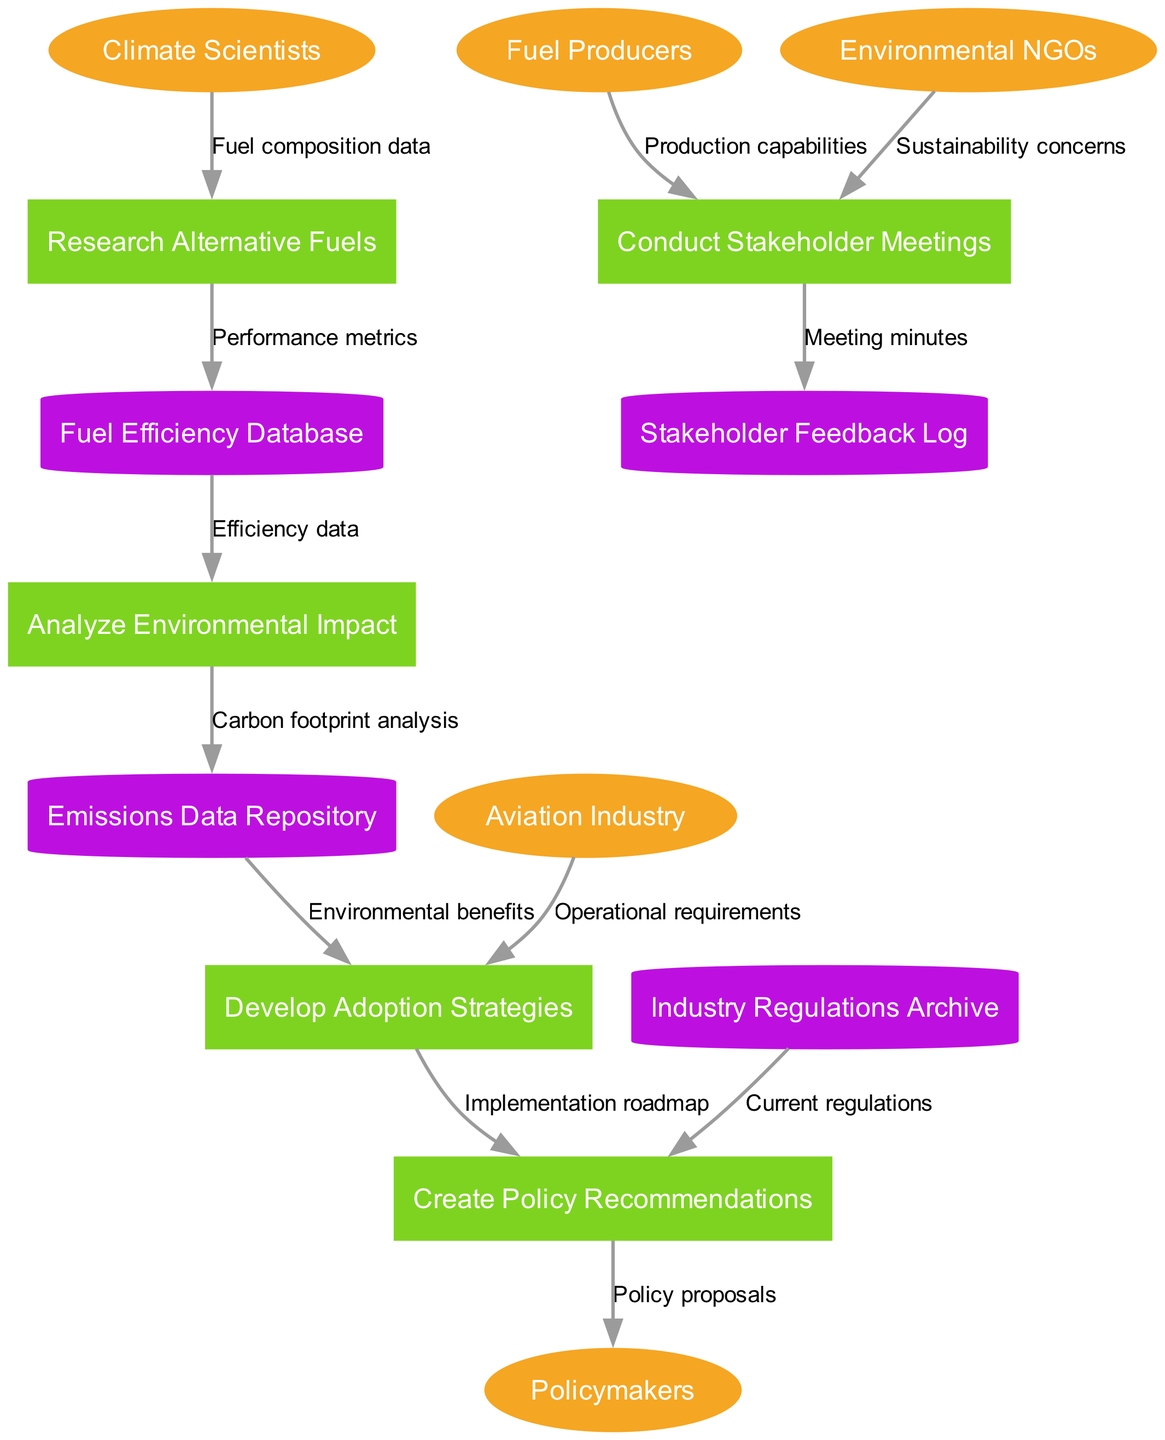What are the external entities in the diagram? The diagram identifies five external entities: Climate Scientists, Aviation Industry, Policymakers, Fuel Producers, and Environmental NGOs.
Answer: Climate Scientists, Aviation Industry, Policymakers, Fuel Producers, Environmental NGOs How many processes are represented in the diagram? There are five processes outlined in the diagram that facilitate the flow of information regarding alternative fuel adoption: Research Alternative Fuels, Analyze Environmental Impact, Develop Adoption Strategies, Create Policy Recommendations, and Conduct Stakeholder Meetings.
Answer: Five What type of data flows from Climate Scientists to Research Alternative Fuels? The data flow is labeled as "Fuel composition data," indicating the specific information being transmitted from Climate Scientists to the process of researching alternative fuels.
Answer: Fuel composition data Which data store is fed by Analyze Environmental Impact? The Emissions Data Repository receives "Carbon footprint analysis" data from the Analyze Environmental Impact process, indicating it serves as a data store that retains relevant environmental information derived from the analysis.
Answer: Emissions Data Repository What type of feedback is logged during Conduct Stakeholder Meetings? The output of the Conduct Stakeholder Meetings process is captured as "Meeting minutes," highlighting the collaborative discussions and outcomes, which are recorded in the Stakeholder Feedback Log.
Answer: Meeting minutes What do Environmental NGOs contribute during stakeholder meetings? Environmental NGOs provide "Sustainability concerns" during the Conduct Stakeholder Meetings process, influencing the dialogue towards environmental considerations in the alternative fuel adoption campaign.
Answer: Sustainability concerns Which process utilizes Efficiency data and for what purpose? Analyze Environmental Impact uses Efficiency data from the Fuel Efficiency Database to assess and measure the environmental implications of the alternative fuels being considered, forming a critical step in the evaluation process.
Answer: Analyze Environmental Impact What represents the link between Fuel Producers and Conduct Stakeholder Meetings? The data flow labeled "Production capabilities" demonstrates the information exchanged between Fuel Producers and the process of Conduct Stakeholder Meetings, indicating that production capabilities are a key topic of discussion.
Answer: Production capabilities How do policies get to Policymakers in the diagram? The policy proposals generated in the Create Policy Recommendations process are directed towards Policymakers, establishing a flow of information aimed at facilitating regulatory changes for alternative fuel adoption.
Answer: Policy proposals 